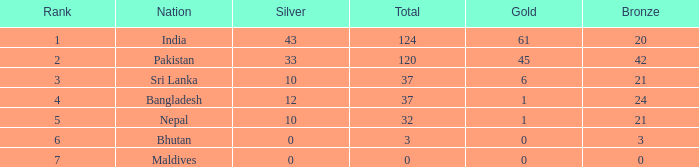In which case does silver have a rank of 6 and bronze is smaller than 3? None. 